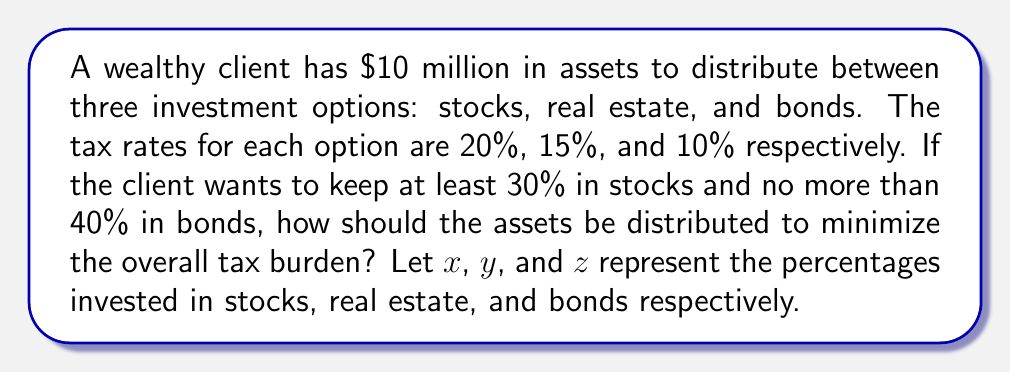What is the answer to this math problem? 1) First, let's set up our system of equations:

   $$x + y + z = 100\%$$ (total distribution must be 100%)
   $$x \geq 30\%$$ (at least 30% in stocks)
   $$z \leq 40\%$$ (no more than 40% in bonds)

2) Our objective is to minimize the tax burden. We can express this as:

   $$\text{Minimize: } 0.20x + 0.15y + 0.10z$$

3) To minimize this expression, we should allocate as much as possible to the lowest tax rate (bonds), then to the second-lowest (real estate), and finally to the highest (stocks).

4) Given the constraints:
   - We should allocate the maximum 40% to bonds: $z = 40\%$
   - We must allocate at least 30% to stocks: $x = 30\%$
   - The remaining 30% goes to real estate: $y = 30\%$

5) Let's verify our solution:
   $$30\% + 30\% + 40\% = 100\%$$
   $$x \geq 30\%$$ is satisfied
   $$z \leq 40\%$$ is satisfied

6) Calculate the tax burden:
   $$0.20(30) + 0.15(30) + 0.10(40) = 6 + 4.5 + 4 = 14.5\%$$

Therefore, the optimal distribution to minimize tax burden is 30% in stocks, 30% in real estate, and 40% in bonds, resulting in a 14.5% overall tax rate.
Answer: 30% stocks, 30% real estate, 40% bonds 